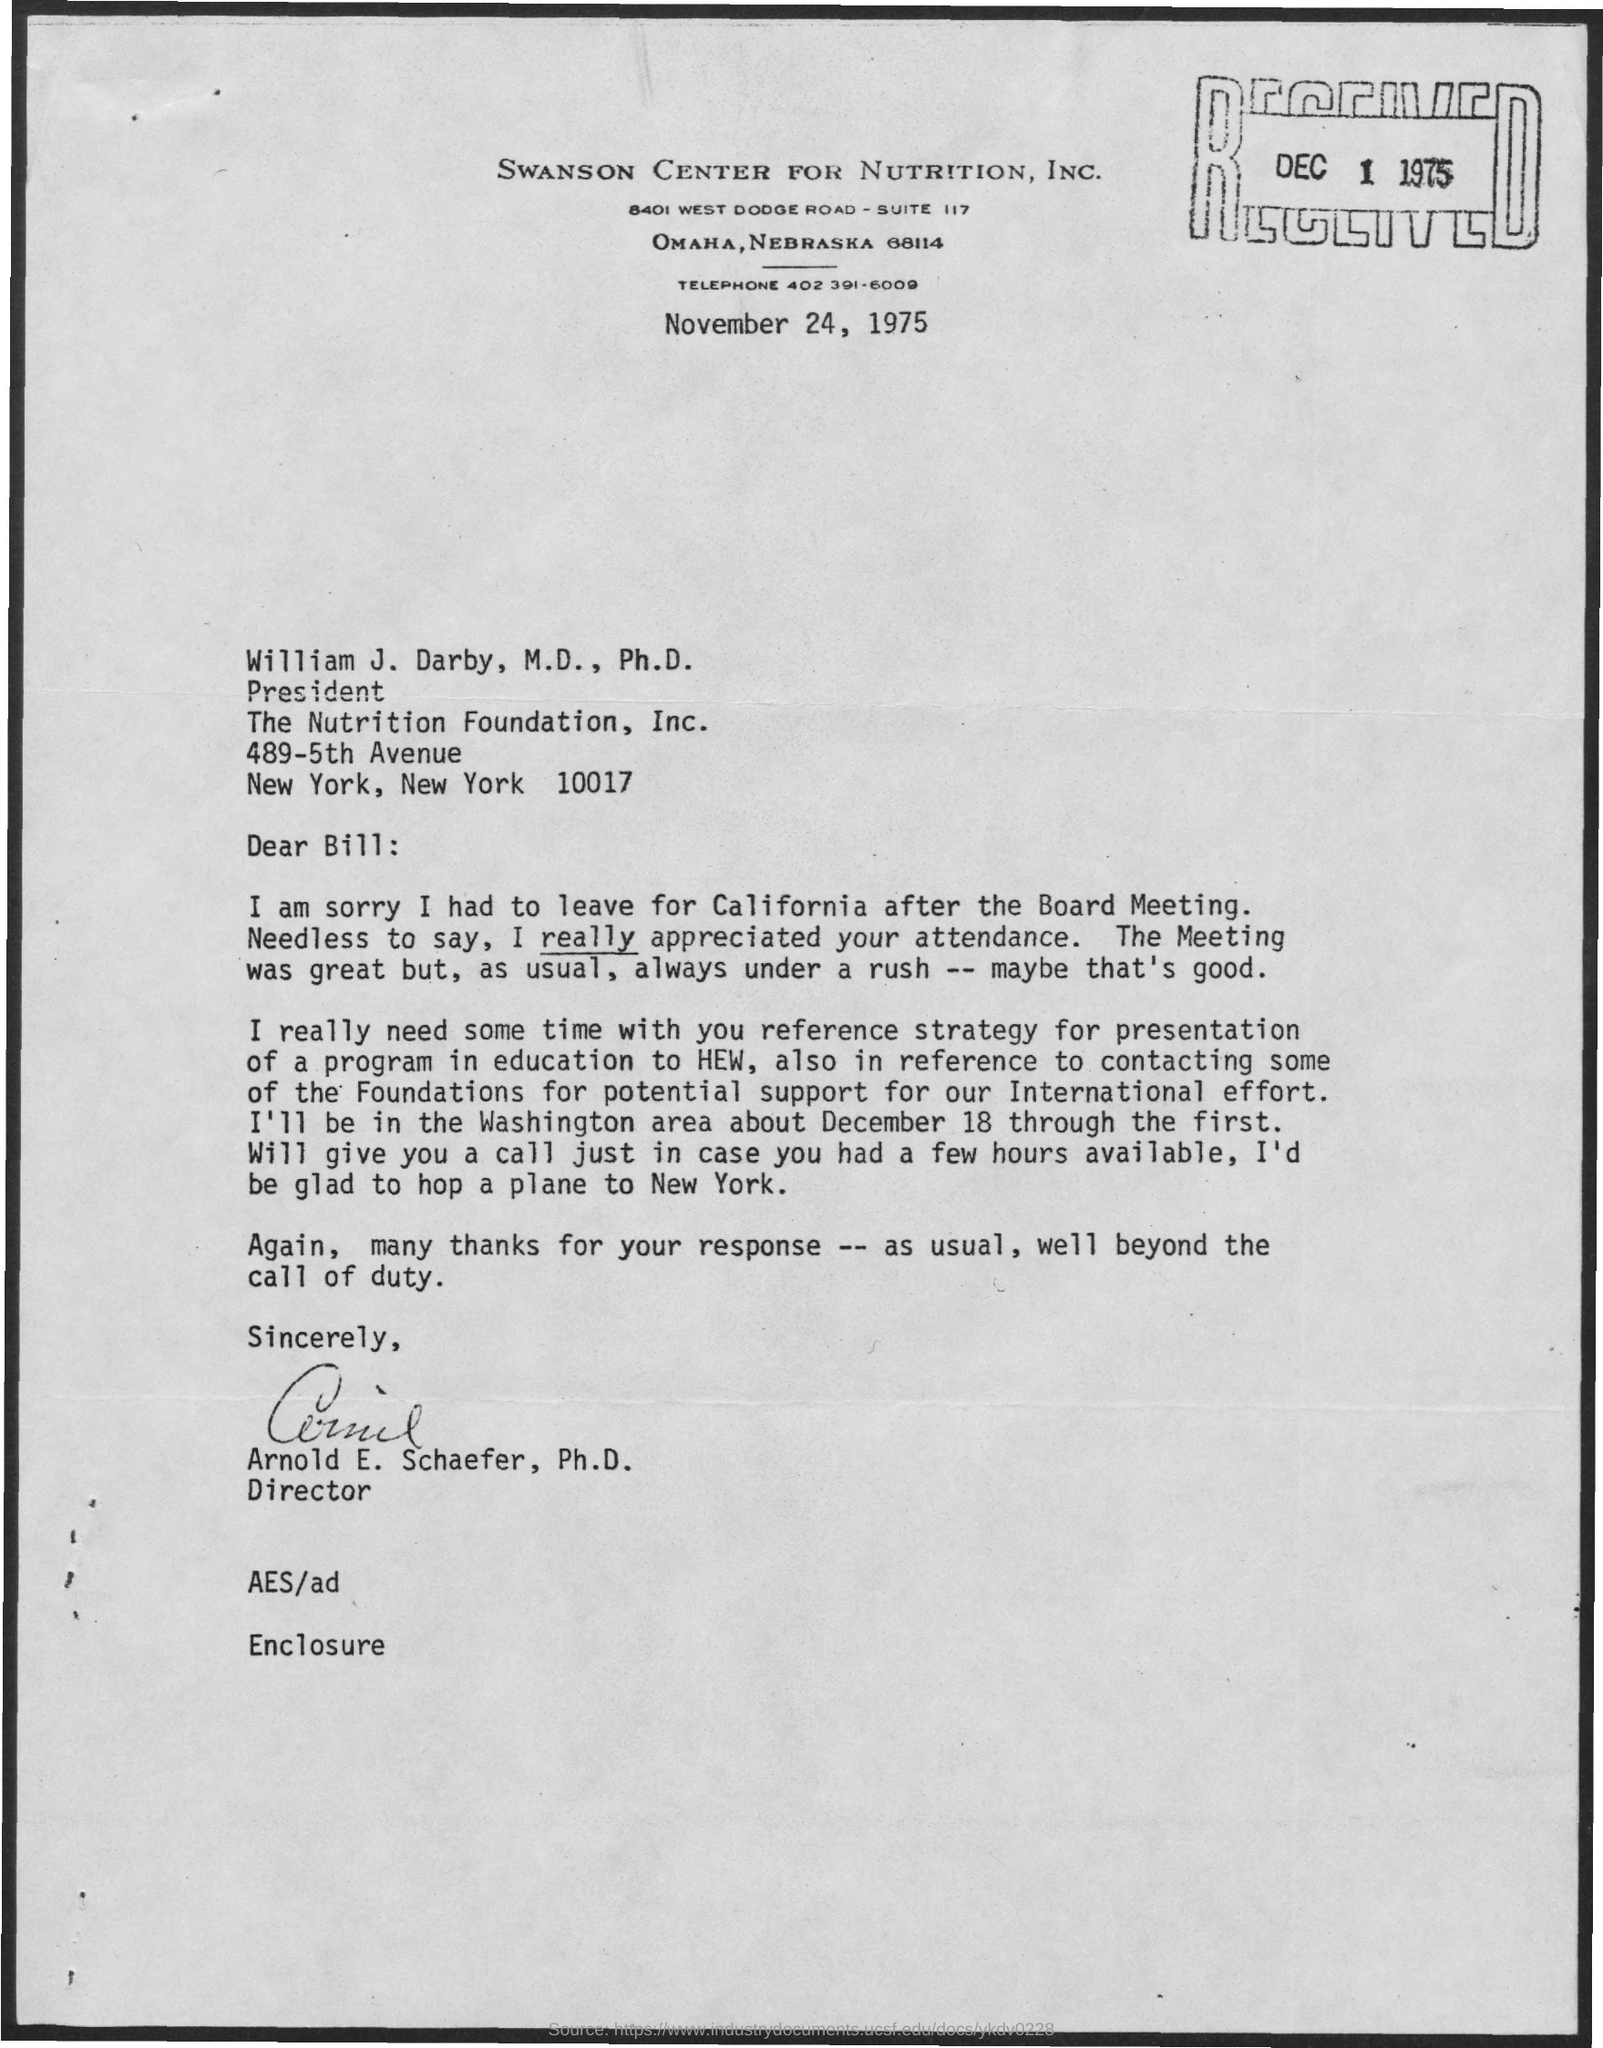What is the Telephone Number?
Provide a succinct answer. 402 391-6009. What is the Suit Number ?
Your answer should be very brief. 117. 